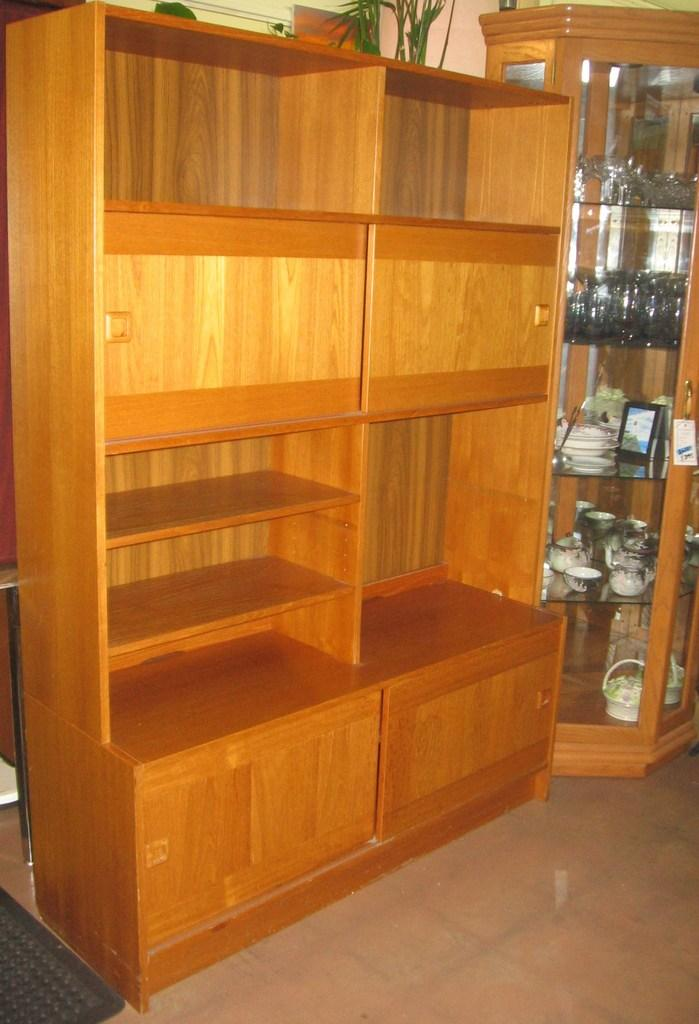What type of furniture is present in the image? There is a wardrobe in the image. What can be seen on the shelves in the image? There are shelves with objects in the image, including glasses. What is visible on the ground in the image? The ground is visible in the image. What type of vegetation is present in the image? There are plants in the image. Where are the objects located in the image? There are objects on the left side of the image. How many brothers are depicted in the image? There are no brothers present in the image. What type of beef can be seen hanging from the wardrobe in the image? There is no beef present in the image; it features a wardrobe with shelves and objects. 